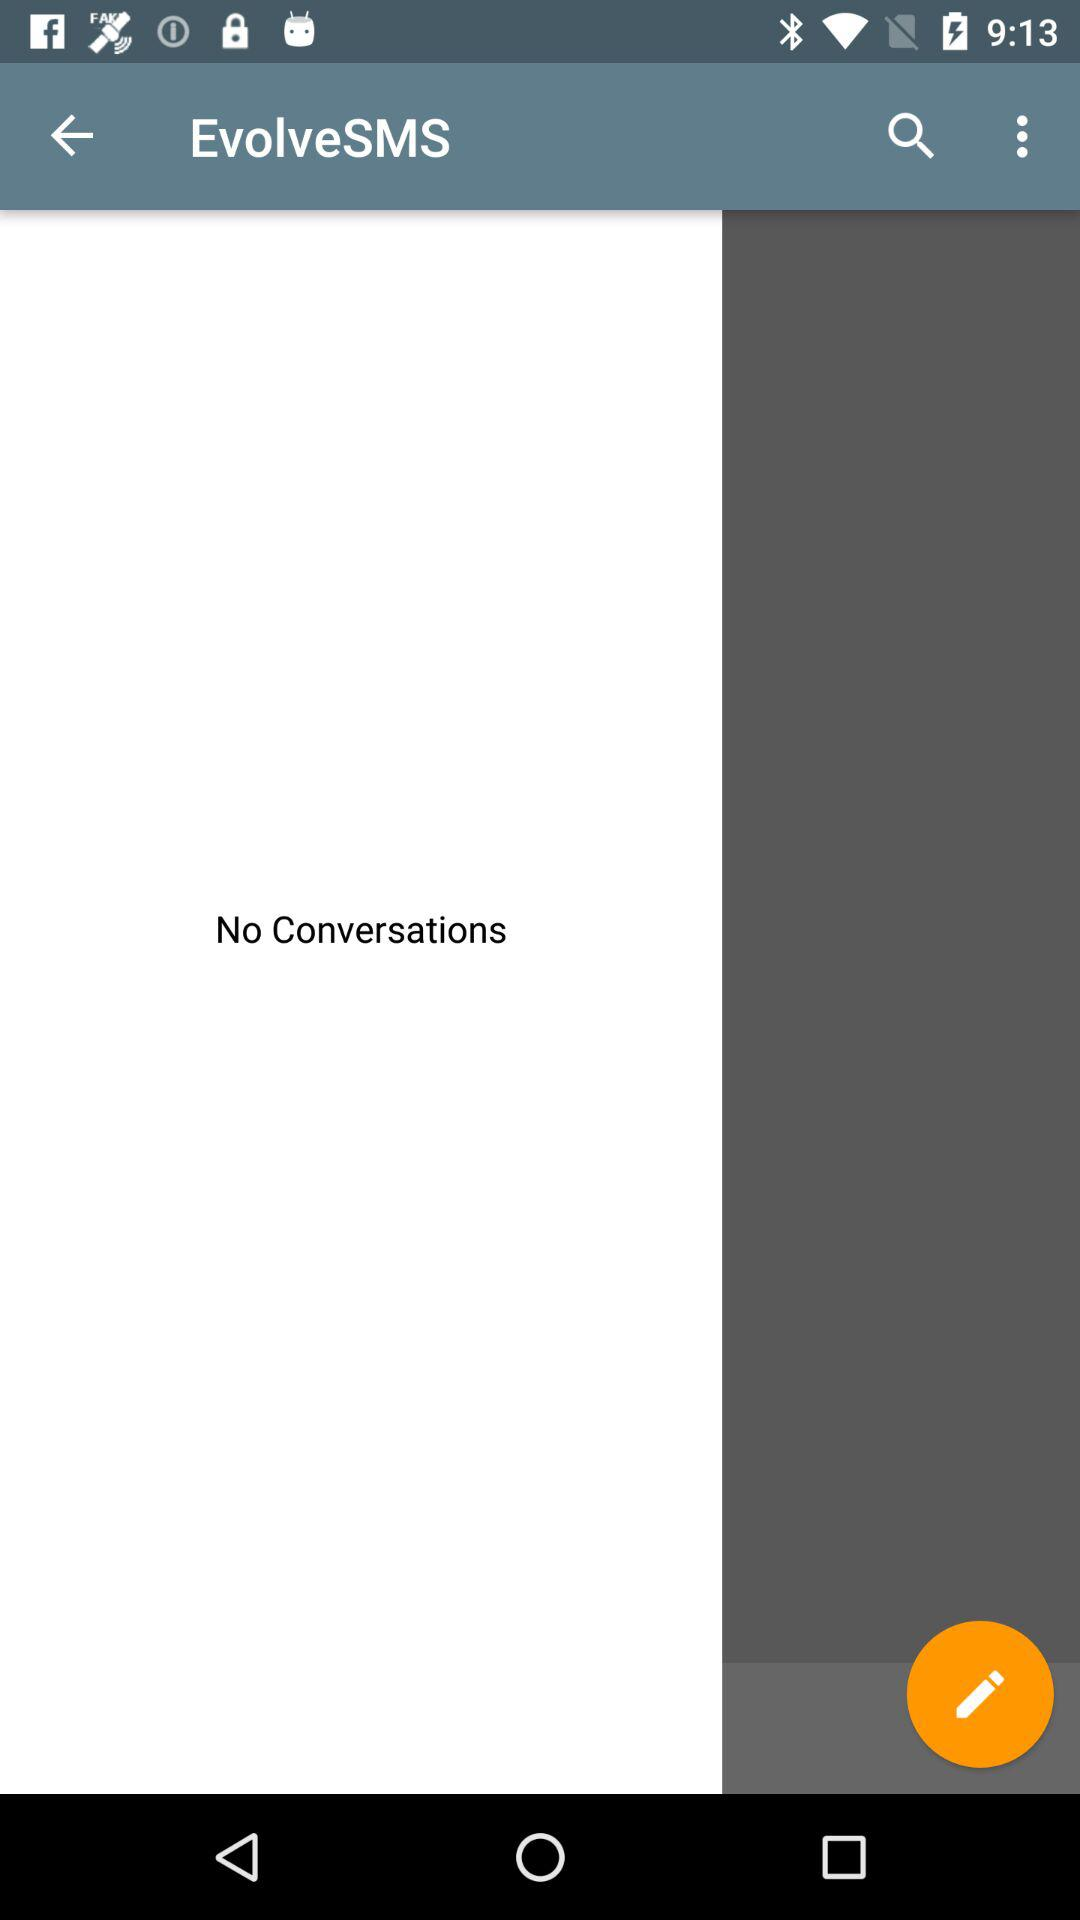What's the number for conversations? There is no number for conversations.. 